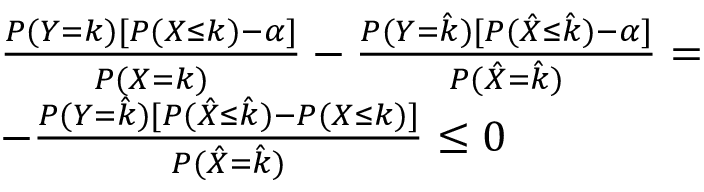<formula> <loc_0><loc_0><loc_500><loc_500>\begin{array} { r l } & { \frac { P ( Y = k ) [ P ( X \leq k ) - \alpha ] } { P ( X = k ) } - \frac { P ( Y = \hat { k } ) [ P ( \hat { X } \leq \hat { k } ) - \alpha ] } { P ( \hat { X } = \hat { k } ) } = } \\ & { - \frac { P ( Y = \hat { k } ) [ P ( \hat { X } \leq \hat { k } ) - P ( X \leq k ) ] } { P ( \hat { X } = \hat { k } ) } \leq 0 } \end{array}</formula> 